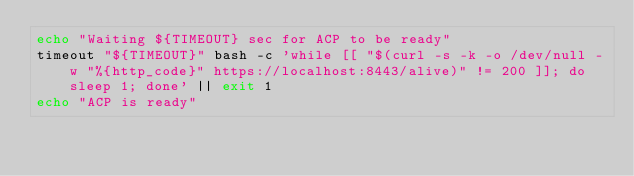<code> <loc_0><loc_0><loc_500><loc_500><_Bash_>echo "Waiting ${TIMEOUT} sec for ACP to be ready"
timeout "${TIMEOUT}" bash -c 'while [[ "$(curl -s -k -o /dev/null -w "%{http_code}" https://localhost:8443/alive)" != 200 ]]; do sleep 1; done' || exit 1
echo "ACP is ready"
</code> 